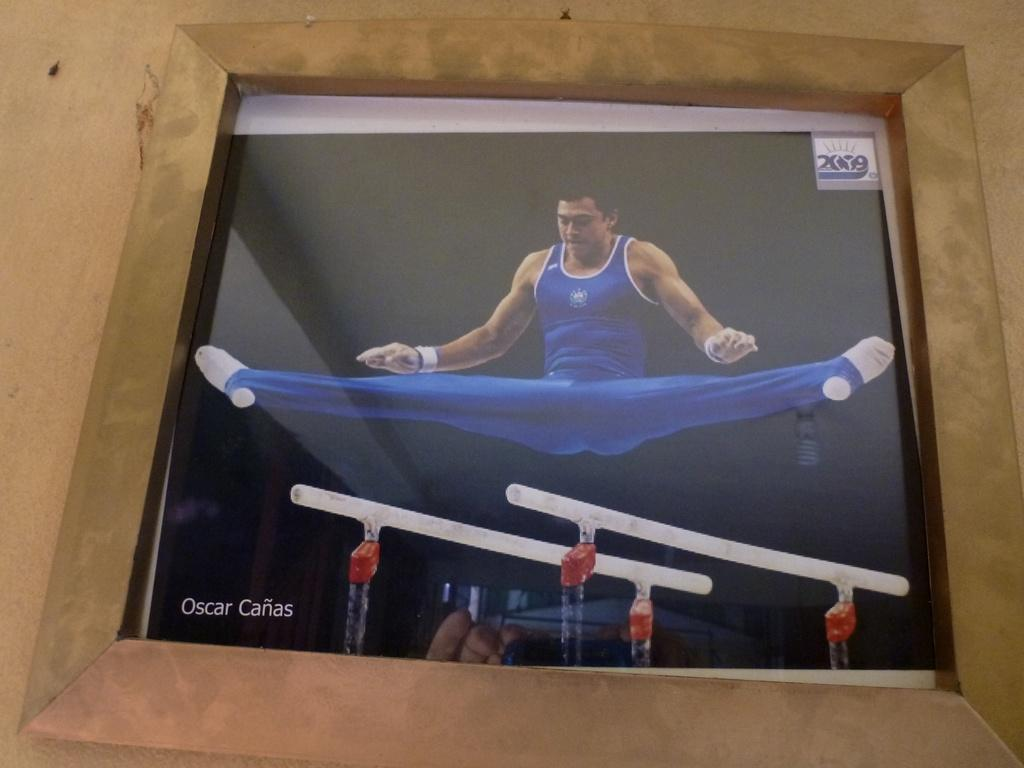Provide a one-sentence caption for the provided image. The gymnast, Oscar Canas, demonstrates his flexibility on the even bars. 